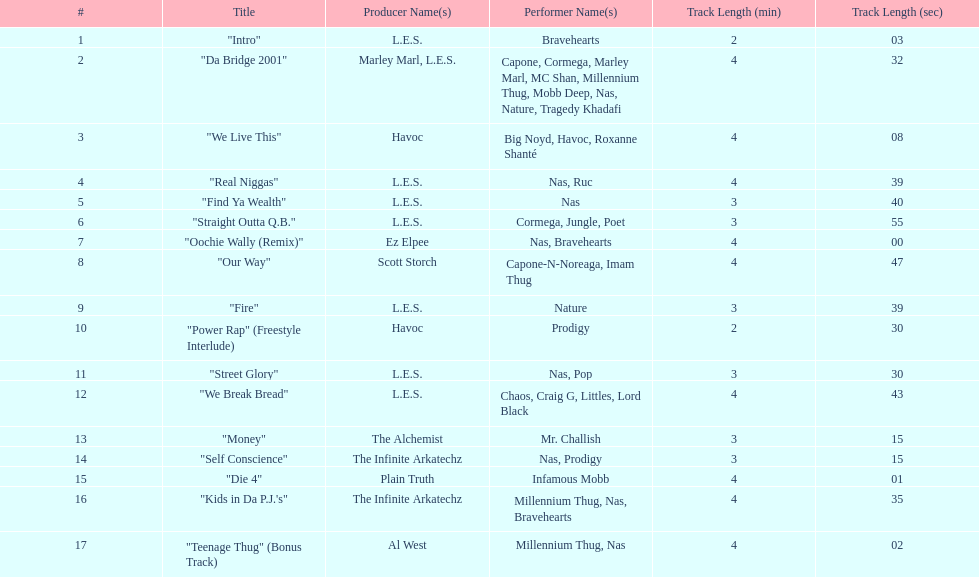What performers were in the last track? Millennium Thug, Nas. 